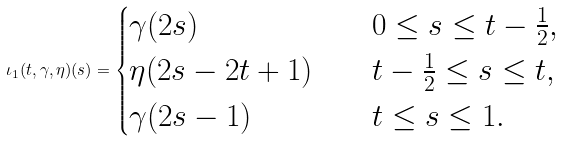<formula> <loc_0><loc_0><loc_500><loc_500>\iota _ { 1 } ( t , \gamma , \eta ) ( s ) = \begin{cases} \gamma ( 2 s ) & 0 \leq s \leq t - \frac { 1 } { 2 } , \\ \eta ( 2 s - 2 t + 1 ) \quad & t - \frac { 1 } { 2 } \leq s \leq t , \\ \gamma ( 2 s - 1 ) & t \leq s \leq 1 . \end{cases}</formula> 